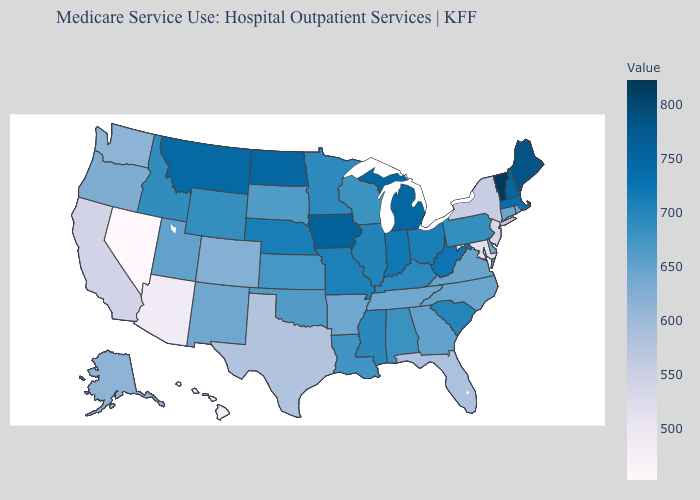Which states have the highest value in the USA?
Concise answer only. Vermont. Does Michigan have a lower value than Vermont?
Answer briefly. Yes. Which states have the lowest value in the Northeast?
Quick response, please. New Jersey. Which states hav the highest value in the Northeast?
Be succinct. Vermont. Does the map have missing data?
Give a very brief answer. No. 